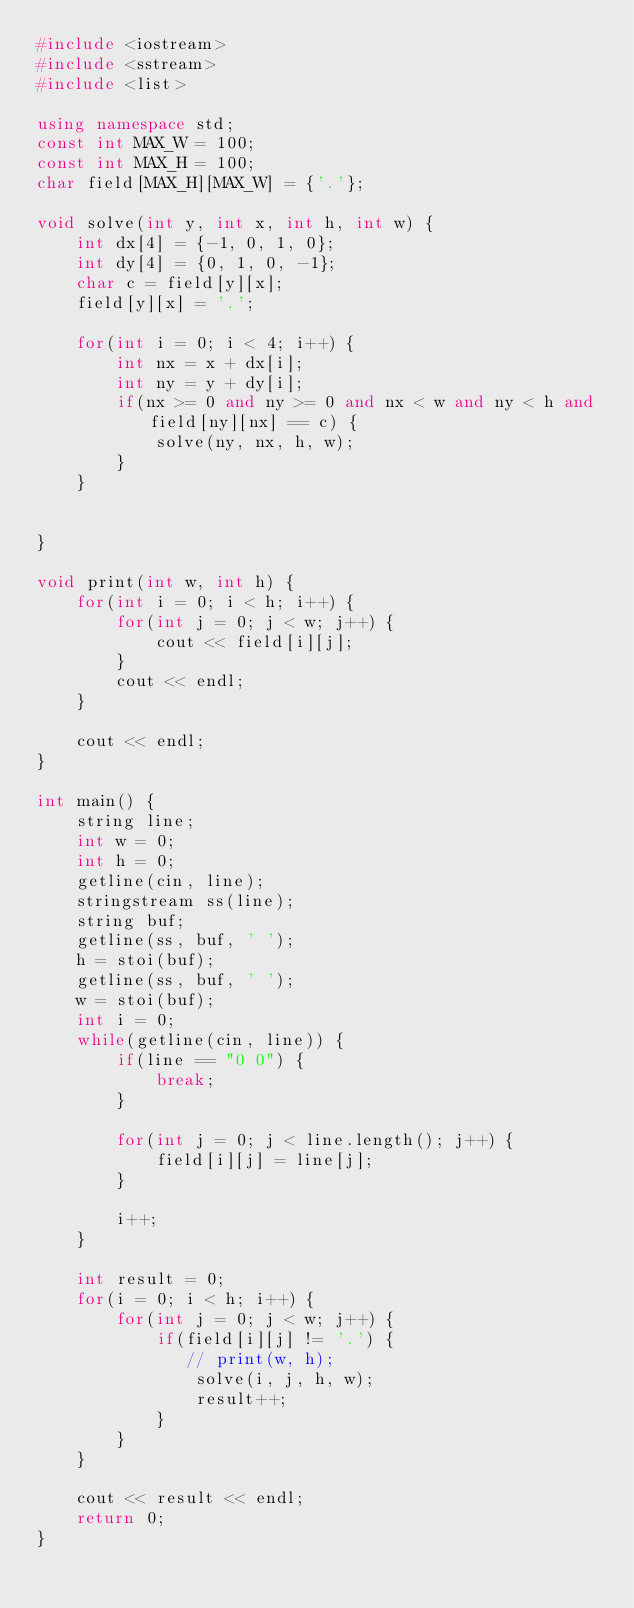<code> <loc_0><loc_0><loc_500><loc_500><_C++_>#include <iostream>
#include <sstream>
#include <list>

using namespace std;
const int MAX_W = 100;
const int MAX_H = 100;
char field[MAX_H][MAX_W] = {'.'};

void solve(int y, int x, int h, int w) {
    int dx[4] = {-1, 0, 1, 0};
    int dy[4] = {0, 1, 0, -1};
    char c = field[y][x];
    field[y][x] = '.';

    for(int i = 0; i < 4; i++) {
        int nx = x + dx[i];
        int ny = y + dy[i];
        if(nx >= 0 and ny >= 0 and nx < w and ny < h and field[ny][nx] == c) {
            solve(ny, nx, h, w);
        }
    }


}

void print(int w, int h) {
    for(int i = 0; i < h; i++) {
        for(int j = 0; j < w; j++) {
            cout << field[i][j];
        }
        cout << endl;
    }

    cout << endl;
}

int main() {
    string line;
    int w = 0;
    int h = 0;
    getline(cin, line);
    stringstream ss(line);
    string buf;
    getline(ss, buf, ' ');
    h = stoi(buf);
    getline(ss, buf, ' ');
    w = stoi(buf);
    int i = 0;
    while(getline(cin, line)) {
        if(line == "0 0") {
            break;
        }

        for(int j = 0; j < line.length(); j++) {
            field[i][j] = line[j];
        }

        i++;
    }

    int result = 0;
    for(i = 0; i < h; i++) {
        for(int j = 0; j < w; j++) {
            if(field[i][j] != '.') {
               // print(w, h);
                solve(i, j, h, w);
                result++;
            }
        }
    }

    cout << result << endl;
    return 0;
}</code> 